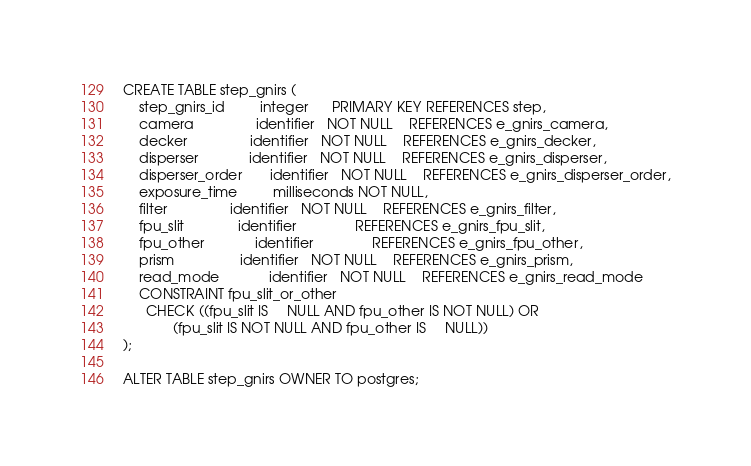Convert code to text. <code><loc_0><loc_0><loc_500><loc_500><_SQL_>CREATE TABLE step_gnirs (
    step_gnirs_id         integer      PRIMARY KEY REFERENCES step,
    camera                identifier   NOT NULL    REFERENCES e_gnirs_camera,
    decker                identifier   NOT NULL    REFERENCES e_gnirs_decker,
    disperser             identifier   NOT NULL    REFERENCES e_gnirs_disperser,
    disperser_order       identifier   NOT NULL    REFERENCES e_gnirs_disperser_order,
    exposure_time         milliseconds NOT NULL,
    filter                identifier   NOT NULL    REFERENCES e_gnirs_filter,
    fpu_slit              identifier               REFERENCES e_gnirs_fpu_slit,
    fpu_other             identifier               REFERENCES e_gnirs_fpu_other,
    prism                 identifier   NOT NULL    REFERENCES e_gnirs_prism,
    read_mode             identifier   NOT NULL    REFERENCES e_gnirs_read_mode
    CONSTRAINT fpu_slit_or_other
      CHECK ((fpu_slit IS     NULL AND fpu_other IS NOT NULL) OR
             (fpu_slit IS NOT NULL AND fpu_other IS     NULL))
);

ALTER TABLE step_gnirs OWNER TO postgres;
</code> 